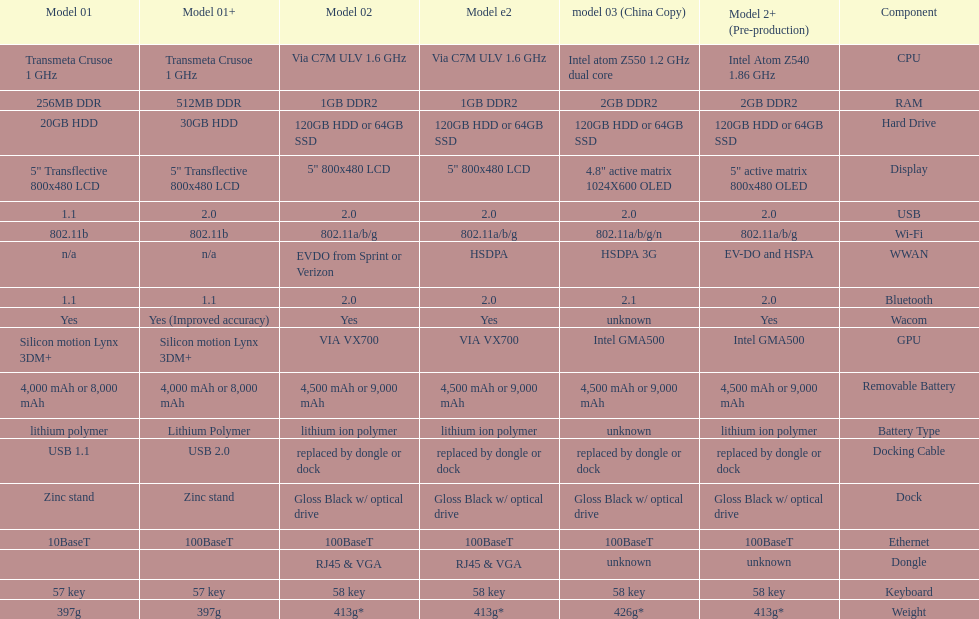How much more weight does the model 3 have over model 1? 29g. 